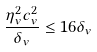<formula> <loc_0><loc_0><loc_500><loc_500>\frac { \eta _ { v } ^ { 2 } c _ { v } ^ { 2 } } { \delta _ { v } } \leq 1 6 \delta _ { v }</formula> 